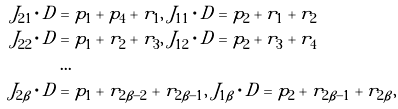Convert formula to latex. <formula><loc_0><loc_0><loc_500><loc_500>J _ { 2 1 } \cdot D & = p _ { 1 } + p _ { 4 } + r _ { 1 } , \ J _ { 1 1 } \cdot D = p _ { 2 } + r _ { 1 } + r _ { 2 } \\ J _ { 2 2 } \cdot D & = p _ { 1 } + r _ { 2 } + r _ { 3 } , \ J _ { 1 2 } \cdot D = p _ { 2 } + r _ { 3 } + r _ { 4 } \\ & \dots \\ J _ { 2 \beta } \cdot D & = p _ { 1 } + r _ { 2 \beta - 2 } + r _ { 2 \beta - 1 } , \ J _ { 1 \beta } \cdot D = p _ { 2 } + r _ { 2 \beta - 1 } + r _ { 2 \beta } ,</formula> 